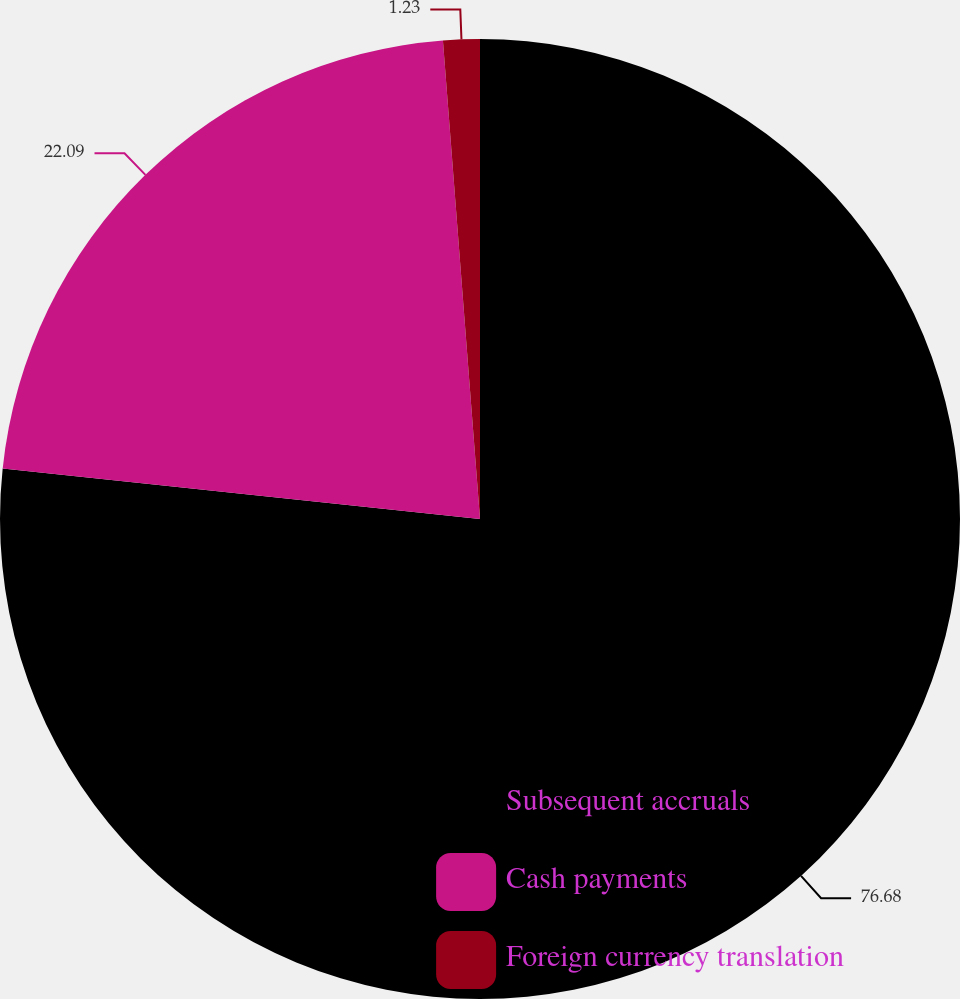Convert chart to OTSL. <chart><loc_0><loc_0><loc_500><loc_500><pie_chart><fcel>Subsequent accruals<fcel>Cash payments<fcel>Foreign currency translation<nl><fcel>76.68%<fcel>22.09%<fcel>1.23%<nl></chart> 